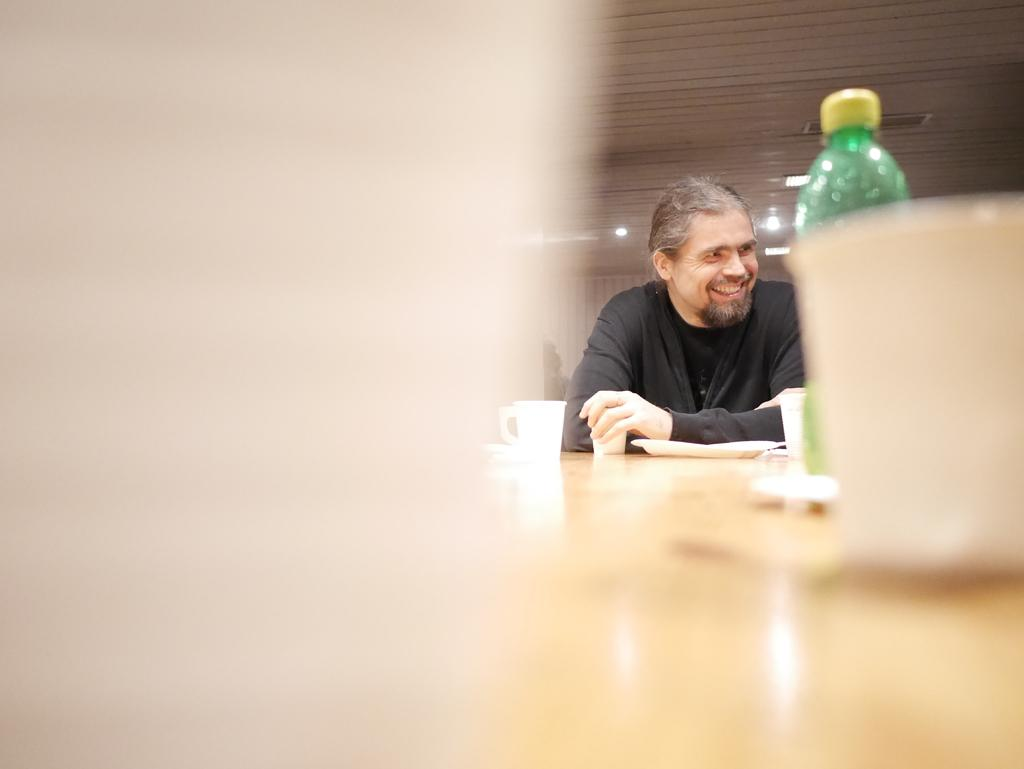Who is present in the image? There is a man in the image. What is the man's facial expression? The man is smiling. What furniture is visible in the image? There is a table in the image. What items can be seen on the table? There are cups and a plate on the table. What other object is present in the image? There is a bottle in the image. What can be seen in the background of the image? There is a light visible in the background. Can you see a window in the image? There is no window mentioned or visible in the image. Is there a bike present in the image? There is no bike present in the image. 